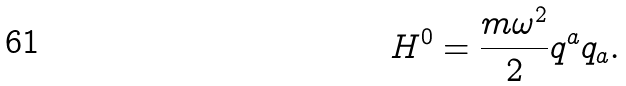<formula> <loc_0><loc_0><loc_500><loc_500>H ^ { 0 } = \frac { m \omega ^ { 2 } } { 2 } q ^ { a } q _ { a } .</formula> 